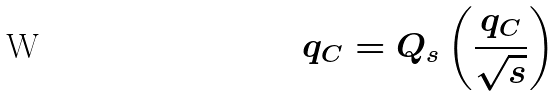<formula> <loc_0><loc_0><loc_500><loc_500>q _ { C } = Q _ { s } \left ( \frac { q _ { C } } { \sqrt { s } } \right )</formula> 